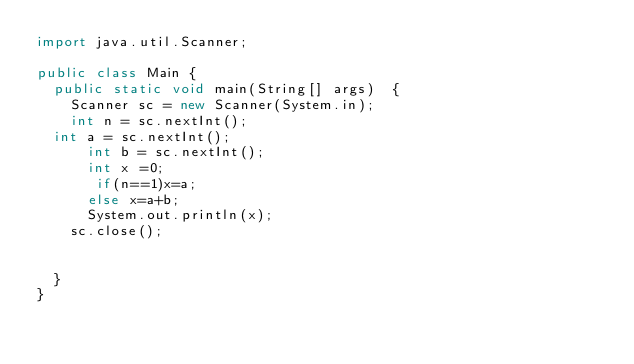<code> <loc_0><loc_0><loc_500><loc_500><_Java_>import java.util.Scanner;

public class Main {
	public static void main(String[] args)  {
		Scanner sc = new Scanner(System.in);
		int n = sc.nextInt();
	int a = sc.nextInt();
      int b = sc.nextInt();
      int x =0;
       if(n==1)x=a;
      else x=a+b;
      System.out.println(x);
		sc.close();
		
		
	}
}
</code> 